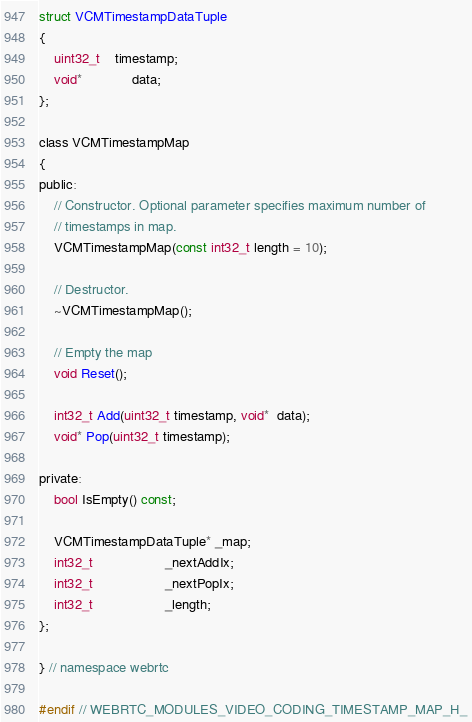Convert code to text. <code><loc_0><loc_0><loc_500><loc_500><_C_>
struct VCMTimestampDataTuple
{
    uint32_t    timestamp;
    void*             data;
};

class VCMTimestampMap
{
public:
    // Constructor. Optional parameter specifies maximum number of
    // timestamps in map.
    VCMTimestampMap(const int32_t length = 10);

    // Destructor.
    ~VCMTimestampMap();

    // Empty the map
    void Reset();

    int32_t Add(uint32_t timestamp, void*  data);
    void* Pop(uint32_t timestamp);

private:
    bool IsEmpty() const;

    VCMTimestampDataTuple* _map;
    int32_t                   _nextAddIx;
    int32_t                   _nextPopIx;
    int32_t                   _length;
};

} // namespace webrtc

#endif // WEBRTC_MODULES_VIDEO_CODING_TIMESTAMP_MAP_H_
</code> 